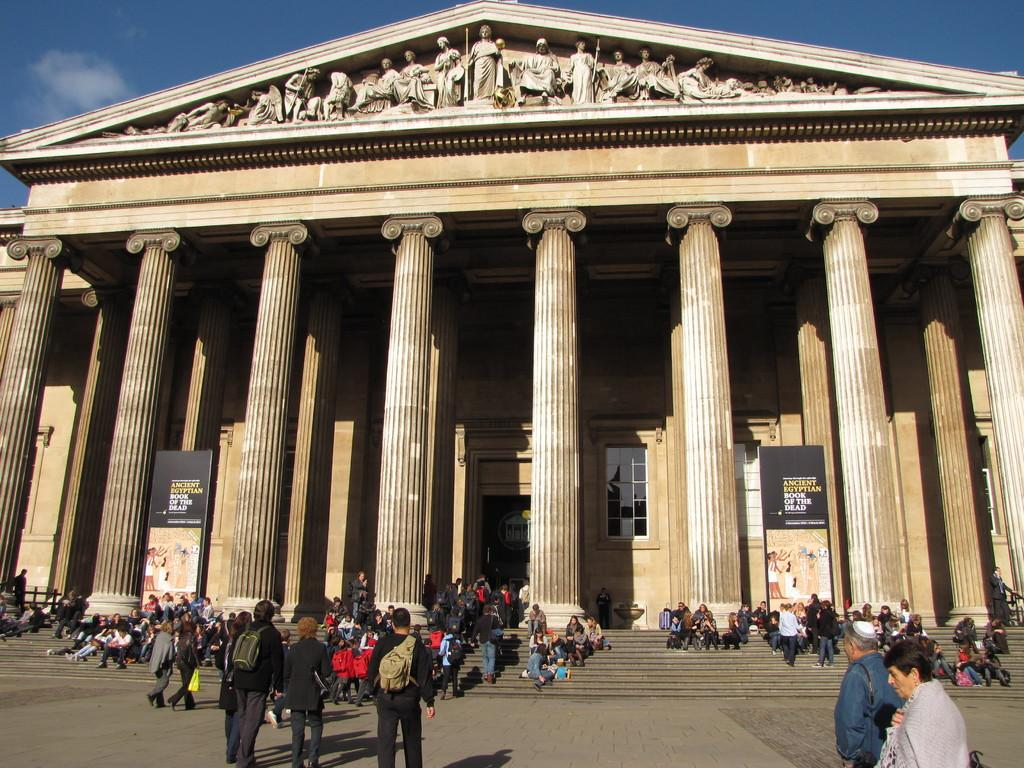<image>
Write a terse but informative summary of the picture. The outside of a building advertising the Ancient Egyptian Book of the Dead 